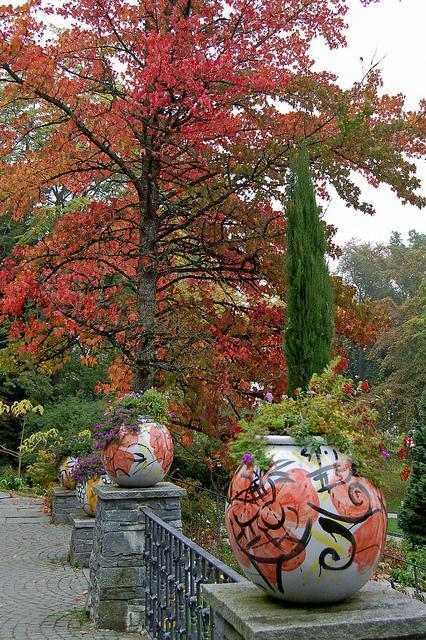How many planter pots are visible?
Give a very brief answer. 2. How many potted plants are in the picture?
Give a very brief answer. 2. How many people are taking pictures?
Give a very brief answer. 0. 